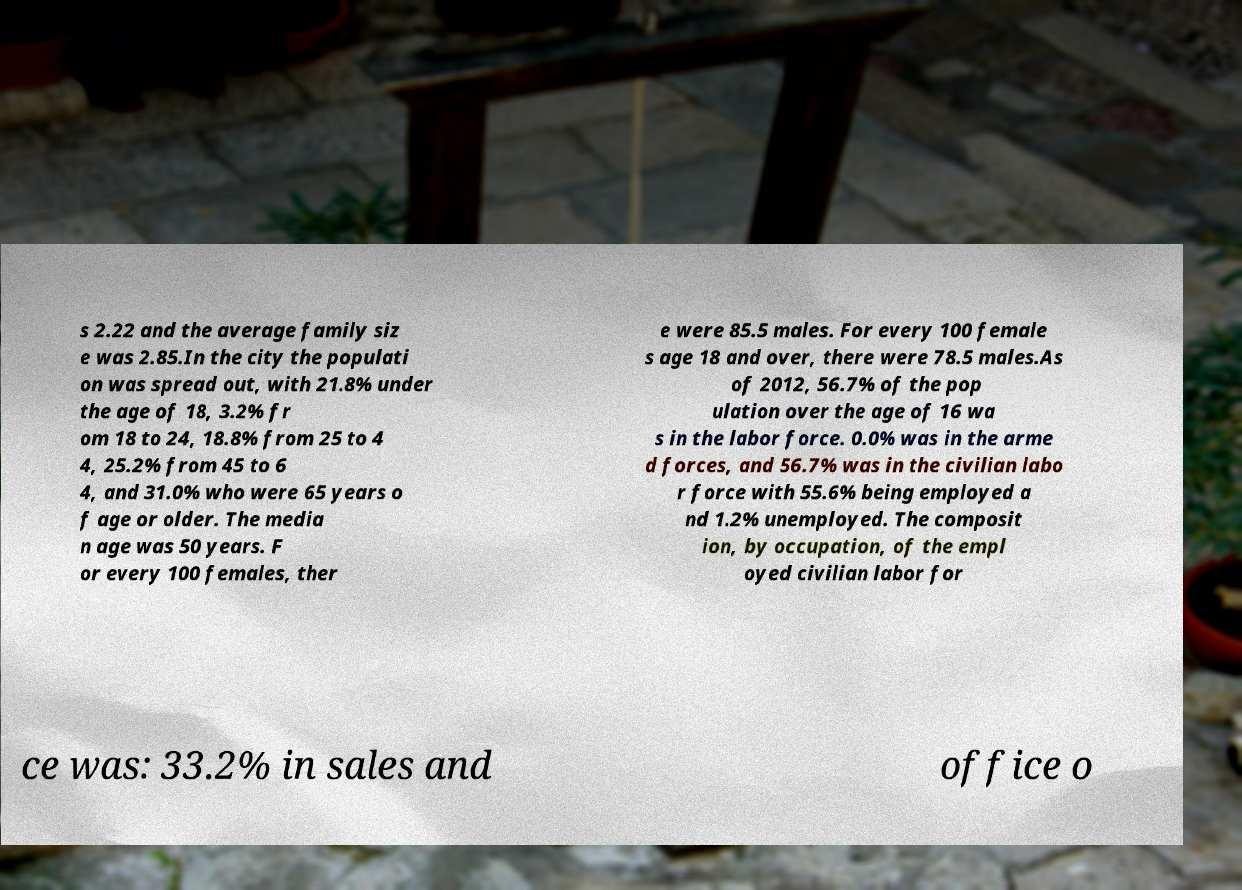What messages or text are displayed in this image? I need them in a readable, typed format. s 2.22 and the average family siz e was 2.85.In the city the populati on was spread out, with 21.8% under the age of 18, 3.2% fr om 18 to 24, 18.8% from 25 to 4 4, 25.2% from 45 to 6 4, and 31.0% who were 65 years o f age or older. The media n age was 50 years. F or every 100 females, ther e were 85.5 males. For every 100 female s age 18 and over, there were 78.5 males.As of 2012, 56.7% of the pop ulation over the age of 16 wa s in the labor force. 0.0% was in the arme d forces, and 56.7% was in the civilian labo r force with 55.6% being employed a nd 1.2% unemployed. The composit ion, by occupation, of the empl oyed civilian labor for ce was: 33.2% in sales and office o 